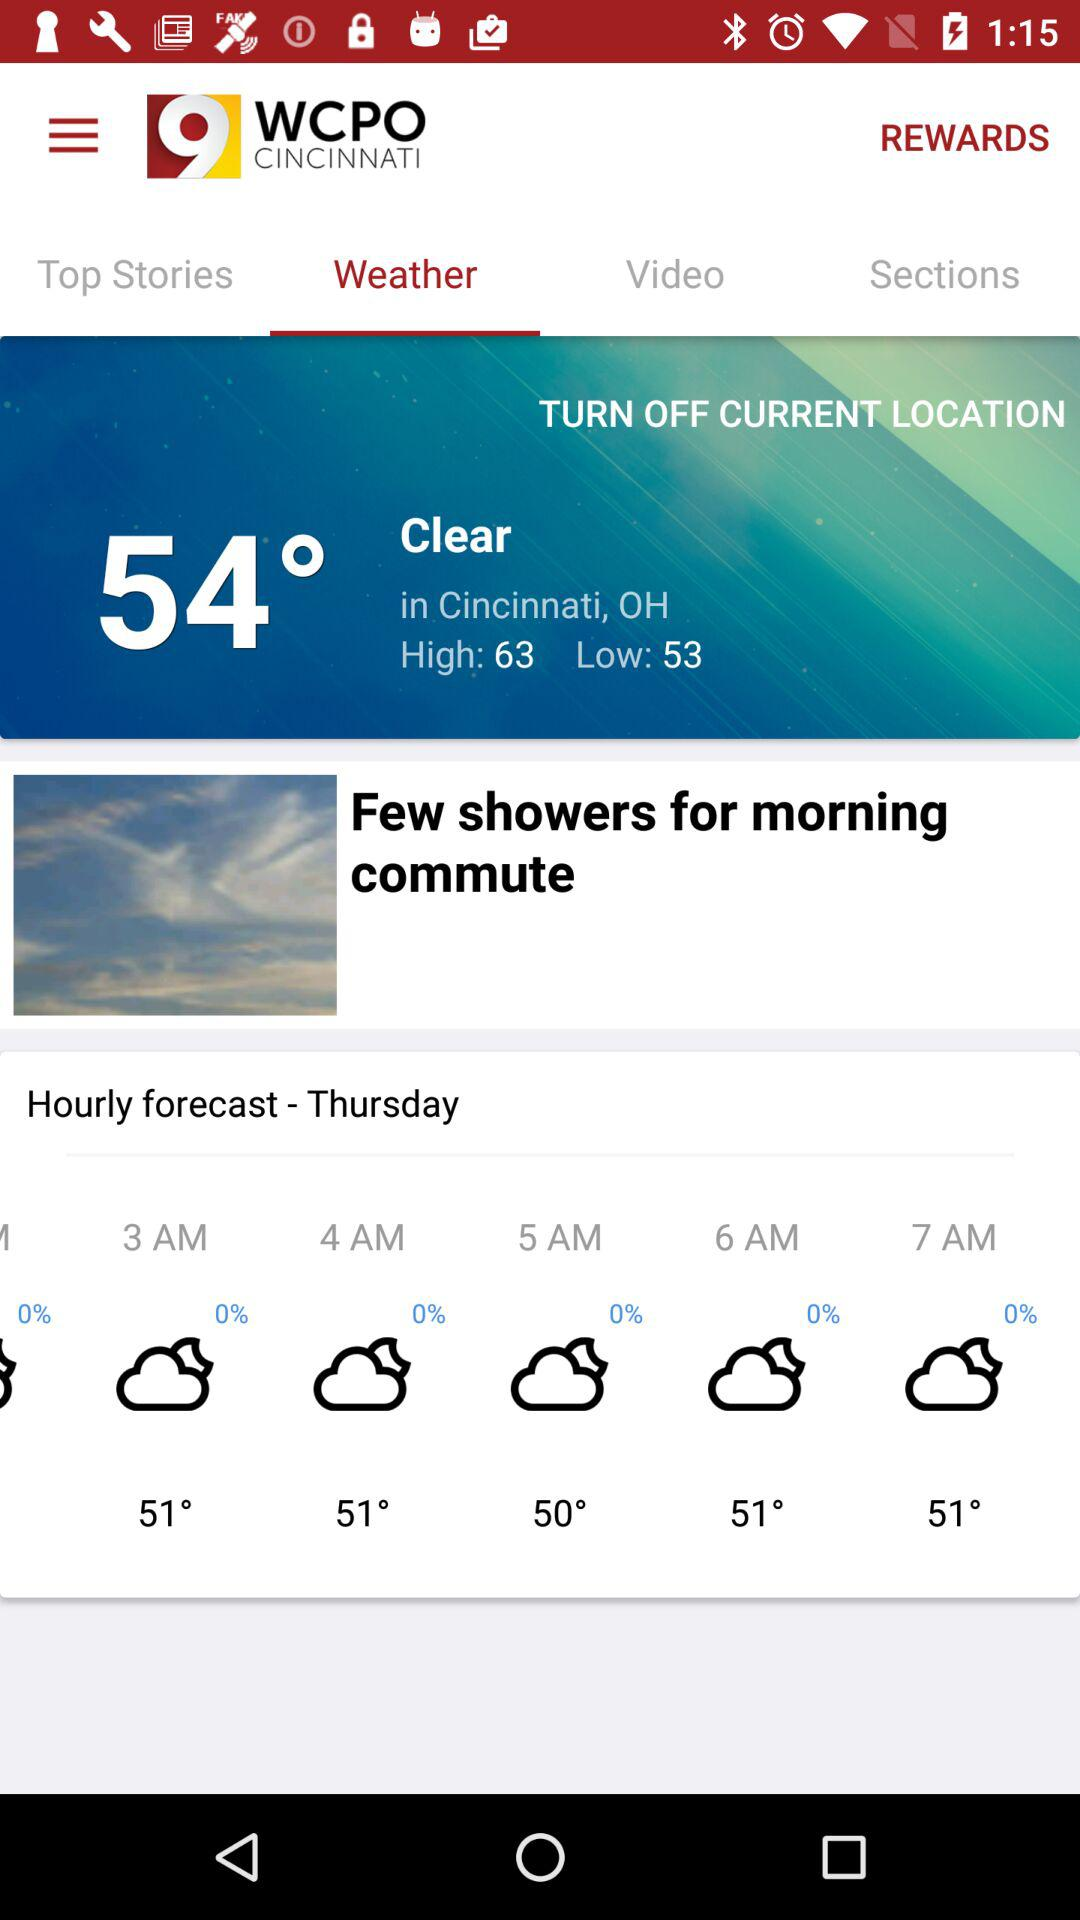What's the current temperature? The current temperature is 54°. 